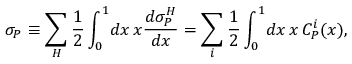<formula> <loc_0><loc_0><loc_500><loc_500>\sigma _ { P } \equiv \sum _ { H } \frac { 1 } { 2 } \int _ { 0 } ^ { 1 } \, d x \, x \frac { d \sigma _ { P } ^ { H } } { d x } = \sum _ { i } \frac { 1 } { 2 } \int _ { 0 } ^ { 1 } \, d x \, x \, C _ { P } ^ { i } ( x ) ,</formula> 